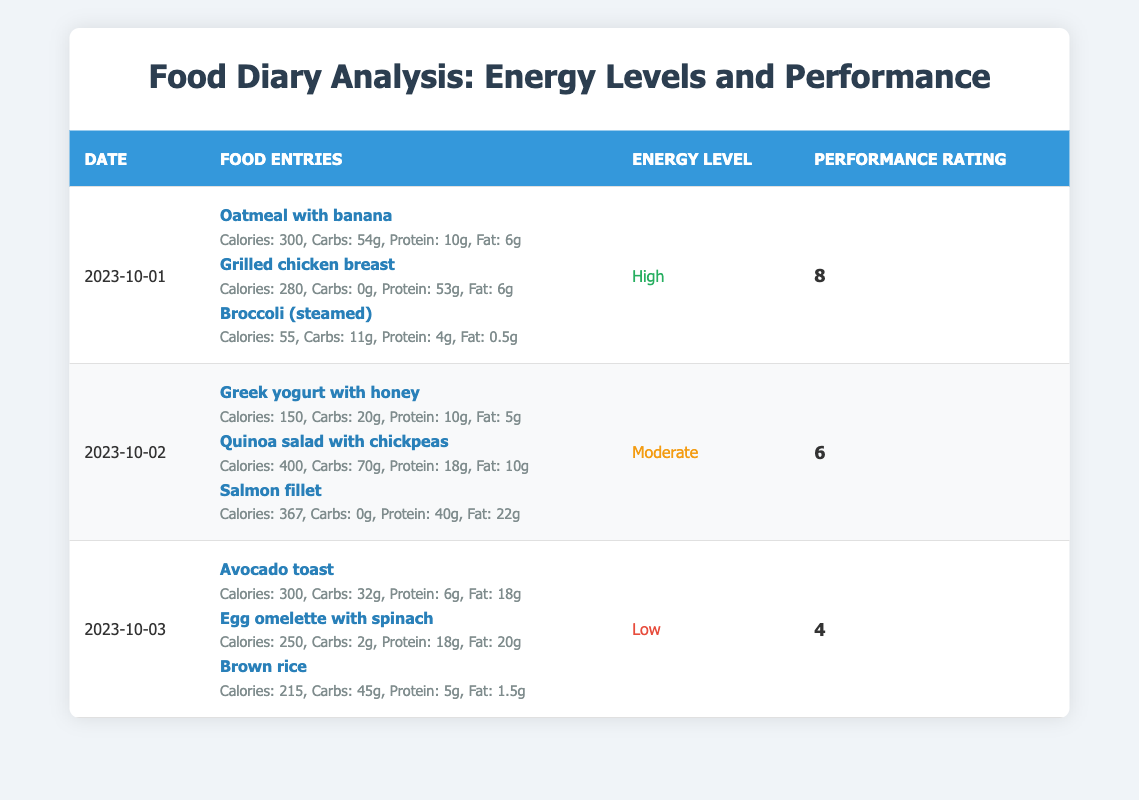What is the energy level associated with the food entries on 2023-10-01? The table shows that on 2023-10-01, the energy level is listed as "High".
Answer: High What was the performance rating on 2023-10-02? Looking at the table, the performance rating for this date is 6.
Answer: 6 Which food entry contributed the most calories on 2023-10-03? On this date, the "Egg omelette with spinach" had 250 calories, which is less than both "Avocado toast" (300 calories) and "Brown rice" (215 calories). Therefore, "Avocado toast" is the entry with the highest calories.
Answer: Avocado toast What is the total calorie intake for 2023-10-02? Adding the calories from the food entries on this date gets us 150 (Greek yogurt) + 400 (Quinoa salad) + 367 (Salmon) = 917 calories.
Answer: 917 Is the performance rating higher on 2023-10-01 compared to 2023-10-03? The performance rating on 2023-10-01 is 8, while on 2023-10-03 it is 4. Since 8 is greater than 4, the performance rating on 2023-10-01 is higher.
Answer: Yes What is the average performance rating over the three dates? To find the average, sum the performance ratings: 8 + 6 + 4 = 18. Then divide by the number of days (3) for the average: 18 / 3 = 6.
Answer: 6 Which day had the highest percentage of protein from total calories consumed? First, we calculate the total calories and total protein for each day. On 2023-10-01: 300 + 280 + 55 = 635 calories (protein: 10 + 53 + 4 = 67g). On 2023-10-02: 150 + 400 + 367 = 917 calories (protein: 10 + 18 + 40 = 68g). On 2023-10-03: 300 + 250 + 215 = 765 calories (protein: 6 + 18 + 5 = 29g). The percentages calculated: Day 1: 67g/635 * 100 = 10.55%, Day 2: 68g/917 * 100 = 7.41%, Day 3: 29g/765 * 100 = 3.79%. The highest percentage of protein is on 2023-10-01.
Answer: 2023-10-01 Did any of the days have a performance rating of 5 or lower? The performance ratings for the three days are 8, 6, and 4. Since 4 is lower than 5, there is at least one day (2023-10-03) with a performance rating of 5 or lower.
Answer: Yes 